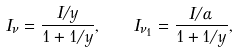<formula> <loc_0><loc_0><loc_500><loc_500>I _ { \nu } = \frac { I / y } { 1 + 1 / y } , \quad I _ { \nu _ { 1 } } = \frac { I / \alpha } { 1 + 1 / y } ,</formula> 